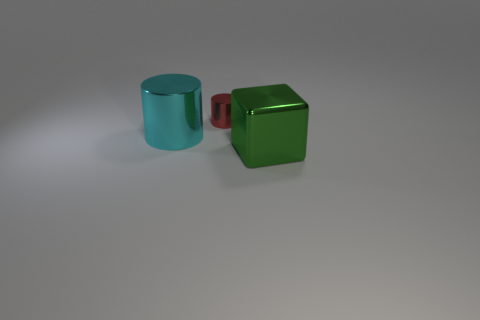Is the green thing made of the same material as the big cyan cylinder?
Give a very brief answer. Yes. What number of tiny red things have the same material as the small red cylinder?
Your response must be concise. 0. How many things are either big shiny objects that are behind the big green metal object or things that are behind the green cube?
Make the answer very short. 2. Are there more cubes that are behind the big shiny cylinder than small things to the right of the small cylinder?
Keep it short and to the point. No. What color is the cylinder in front of the small shiny thing?
Provide a succinct answer. Cyan. Are there any small red objects of the same shape as the cyan metallic object?
Your answer should be compact. Yes. What number of brown things are either small objects or metal cylinders?
Make the answer very short. 0. Are there any green rubber things that have the same size as the block?
Make the answer very short. No. What number of small metallic spheres are there?
Provide a short and direct response. 0. What number of tiny things are purple cylinders or green metal objects?
Offer a very short reply. 0. 